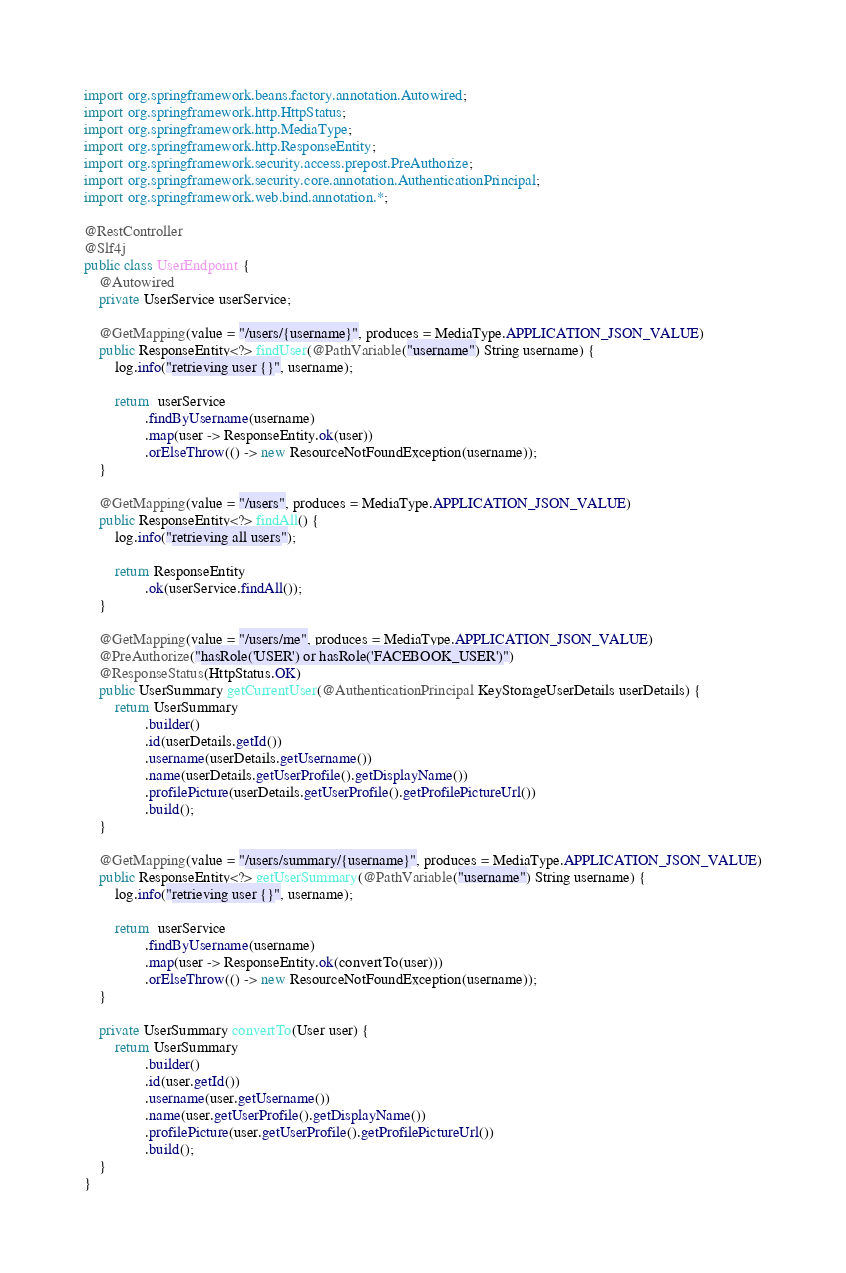Convert code to text. <code><loc_0><loc_0><loc_500><loc_500><_Java_>import org.springframework.beans.factory.annotation.Autowired;
import org.springframework.http.HttpStatus;
import org.springframework.http.MediaType;
import org.springframework.http.ResponseEntity;
import org.springframework.security.access.prepost.PreAuthorize;
import org.springframework.security.core.annotation.AuthenticationPrincipal;
import org.springframework.web.bind.annotation.*;

@RestController
@Slf4j
public class UserEndpoint {
    @Autowired
    private UserService userService;

    @GetMapping(value = "/users/{username}", produces = MediaType.APPLICATION_JSON_VALUE)
    public ResponseEntity<?> findUser(@PathVariable("username") String username) {
        log.info("retrieving user {}", username);

        return  userService
                .findByUsername(username)
                .map(user -> ResponseEntity.ok(user))
                .orElseThrow(() -> new ResourceNotFoundException(username));
    }

    @GetMapping(value = "/users", produces = MediaType.APPLICATION_JSON_VALUE)
    public ResponseEntity<?> findAll() {
        log.info("retrieving all users");

        return ResponseEntity
                .ok(userService.findAll());
    }

    @GetMapping(value = "/users/me", produces = MediaType.APPLICATION_JSON_VALUE)
    @PreAuthorize("hasRole('USER') or hasRole('FACEBOOK_USER')")
    @ResponseStatus(HttpStatus.OK)
    public UserSummary getCurrentUser(@AuthenticationPrincipal KeyStorageUserDetails userDetails) {
        return UserSummary
                .builder()
                .id(userDetails.getId())
                .username(userDetails.getUsername())
                .name(userDetails.getUserProfile().getDisplayName())
                .profilePicture(userDetails.getUserProfile().getProfilePictureUrl())
                .build();
    }

    @GetMapping(value = "/users/summary/{username}", produces = MediaType.APPLICATION_JSON_VALUE)
    public ResponseEntity<?> getUserSummary(@PathVariable("username") String username) {
        log.info("retrieving user {}", username);

        return  userService
                .findByUsername(username)
                .map(user -> ResponseEntity.ok(convertTo(user)))
                .orElseThrow(() -> new ResourceNotFoundException(username));
    }

    private UserSummary convertTo(User user) {
        return UserSummary
                .builder()
                .id(user.getId())
                .username(user.getUsername())
                .name(user.getUserProfile().getDisplayName())
                .profilePicture(user.getUserProfile().getProfilePictureUrl())
                .build();
    }
}
</code> 